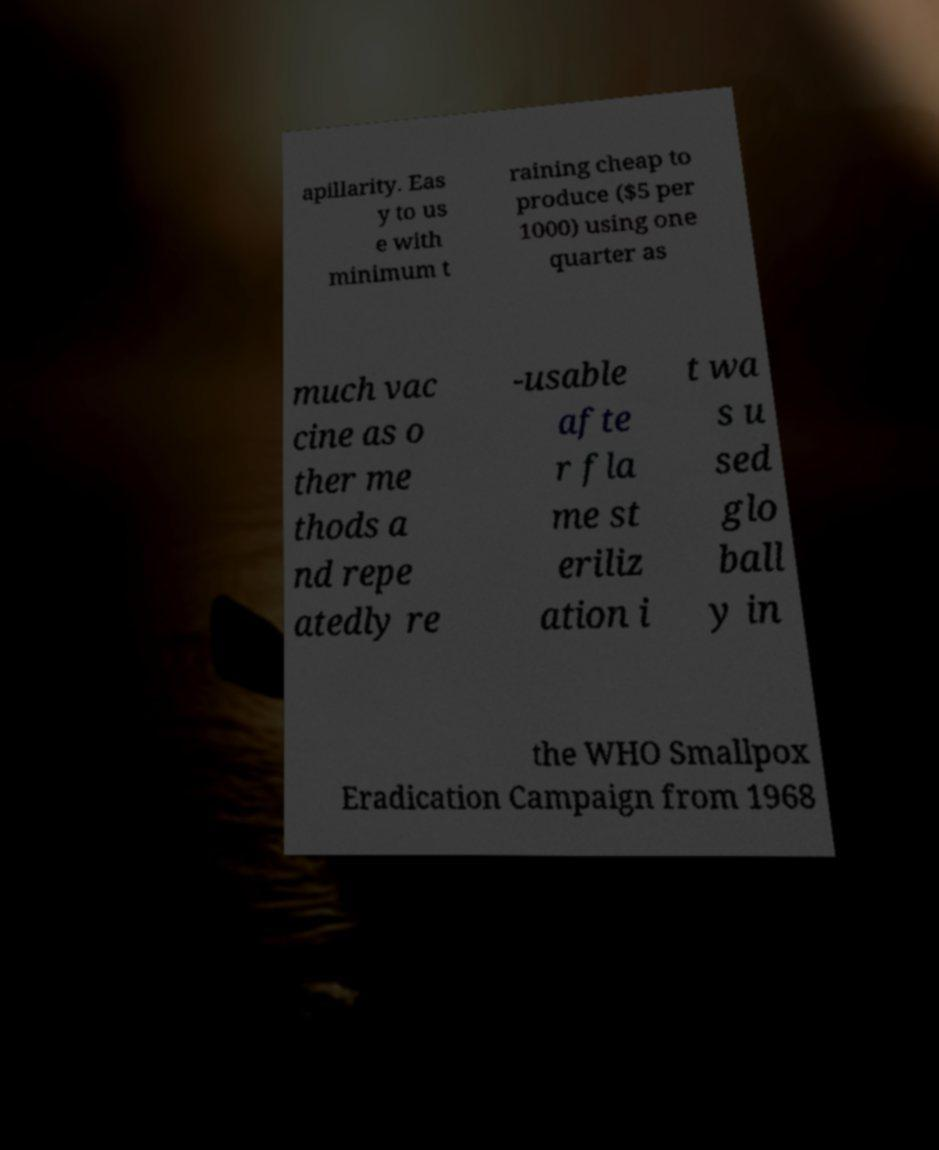Could you assist in decoding the text presented in this image and type it out clearly? apillarity. Eas y to us e with minimum t raining cheap to produce ($5 per 1000) using one quarter as much vac cine as o ther me thods a nd repe atedly re -usable afte r fla me st eriliz ation i t wa s u sed glo ball y in the WHO Smallpox Eradication Campaign from 1968 